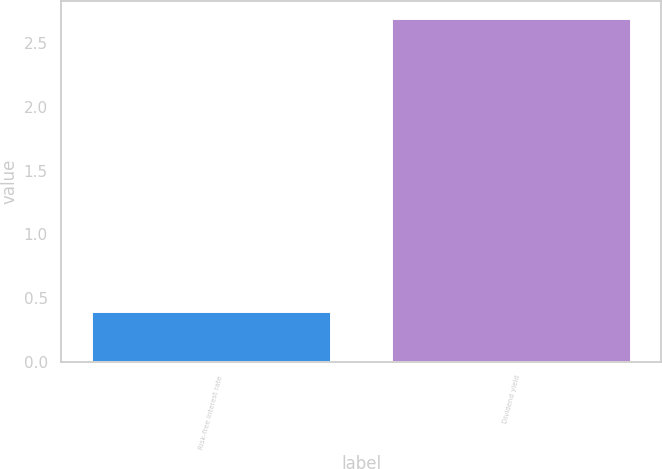<chart> <loc_0><loc_0><loc_500><loc_500><bar_chart><fcel>Risk-free interest rate<fcel>Dividend yield<nl><fcel>0.4<fcel>2.7<nl></chart> 